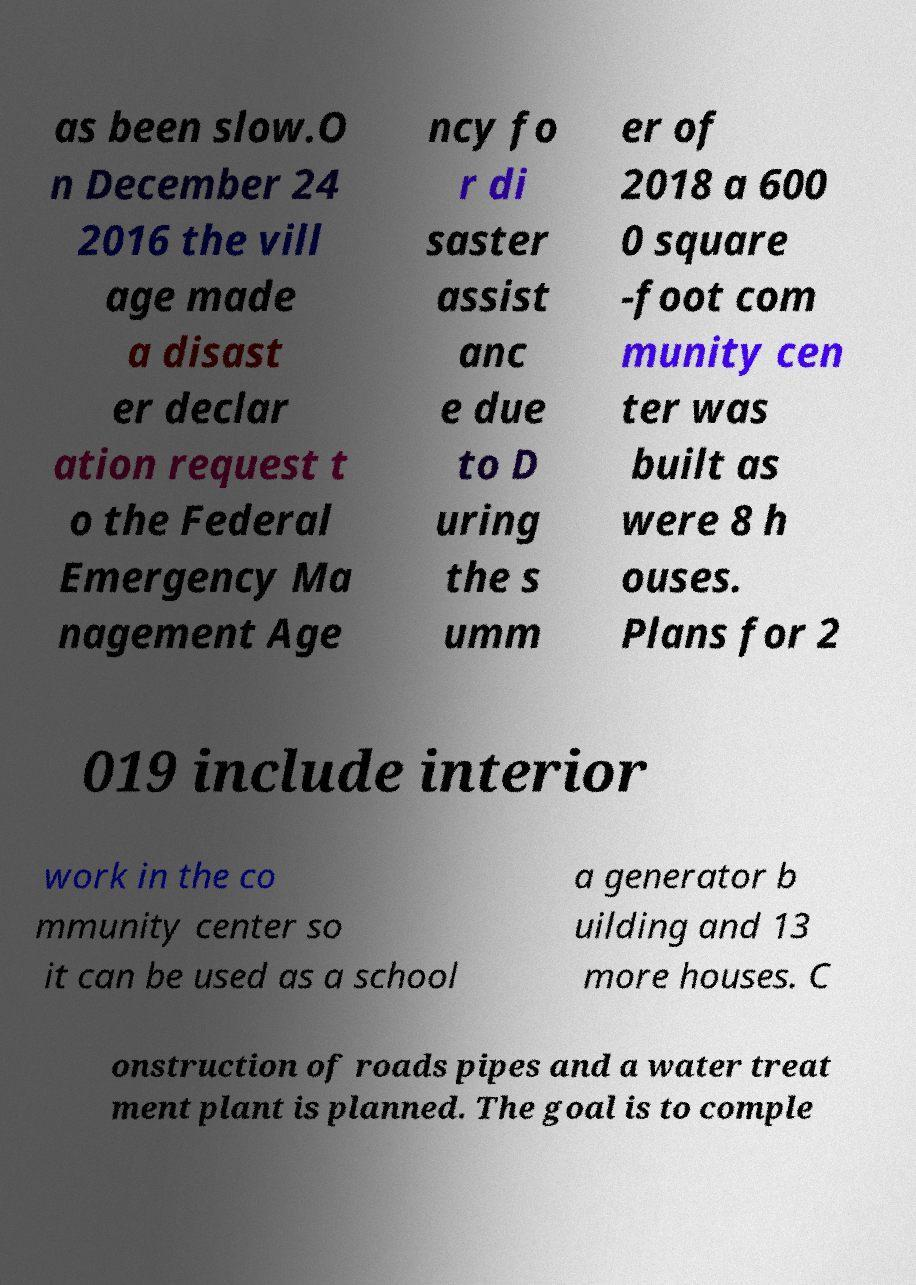There's text embedded in this image that I need extracted. Can you transcribe it verbatim? as been slow.O n December 24 2016 the vill age made a disast er declar ation request t o the Federal Emergency Ma nagement Age ncy fo r di saster assist anc e due to D uring the s umm er of 2018 a 600 0 square -foot com munity cen ter was built as were 8 h ouses. Plans for 2 019 include interior work in the co mmunity center so it can be used as a school a generator b uilding and 13 more houses. C onstruction of roads pipes and a water treat ment plant is planned. The goal is to comple 